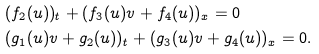<formula> <loc_0><loc_0><loc_500><loc_500>& ( f _ { 2 } ( u ) ) _ { t } + ( f _ { 3 } ( u ) v + f _ { 4 } ( u ) ) _ { x } = 0 \\ & ( g _ { 1 } ( u ) v + g _ { 2 } ( u ) ) _ { t } + ( g _ { 3 } ( u ) v + g _ { 4 } ( u ) ) _ { x } = 0 .</formula> 